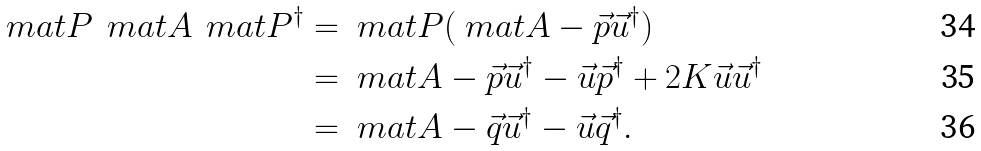<formula> <loc_0><loc_0><loc_500><loc_500>\ m a t { P } \, \ m a t { A } \, \ m a t { P } ^ { \dag } & = \ m a t { P } ( \ m a t { A } - \vec { p } \vec { u } ^ { \dag } ) \\ & = \ m a t { A } - \vec { p } \vec { u } ^ { \dag } - \vec { u } \vec { p } ^ { \dag } + 2 K \vec { u } \vec { u } ^ { \dag } \\ & = \ m a t { A } - \vec { q } \vec { u } ^ { \dag } - \vec { u } \vec { q } ^ { \dag } .</formula> 